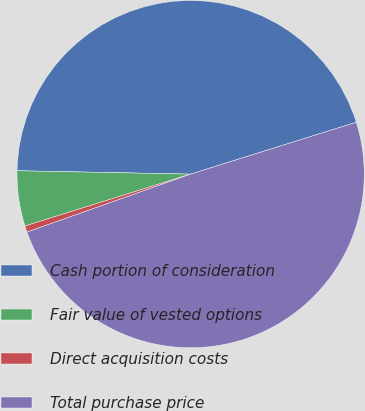Convert chart. <chart><loc_0><loc_0><loc_500><loc_500><pie_chart><fcel>Cash portion of consideration<fcel>Fair value of vested options<fcel>Direct acquisition costs<fcel>Total purchase price<nl><fcel>44.86%<fcel>5.14%<fcel>0.59%<fcel>49.41%<nl></chart> 